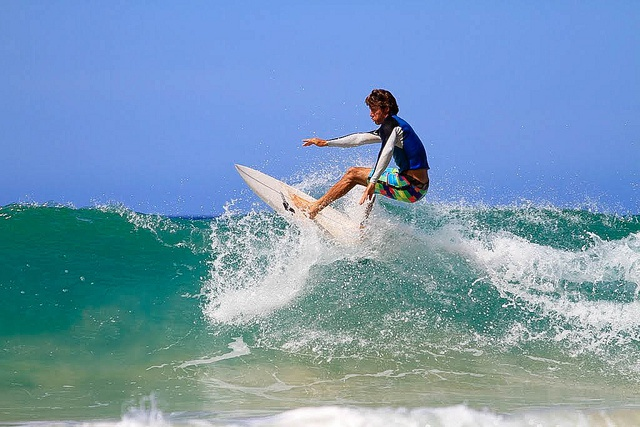Describe the objects in this image and their specific colors. I can see people in gray, black, lightgray, maroon, and navy tones and surfboard in gray, lightgray, and darkgray tones in this image. 